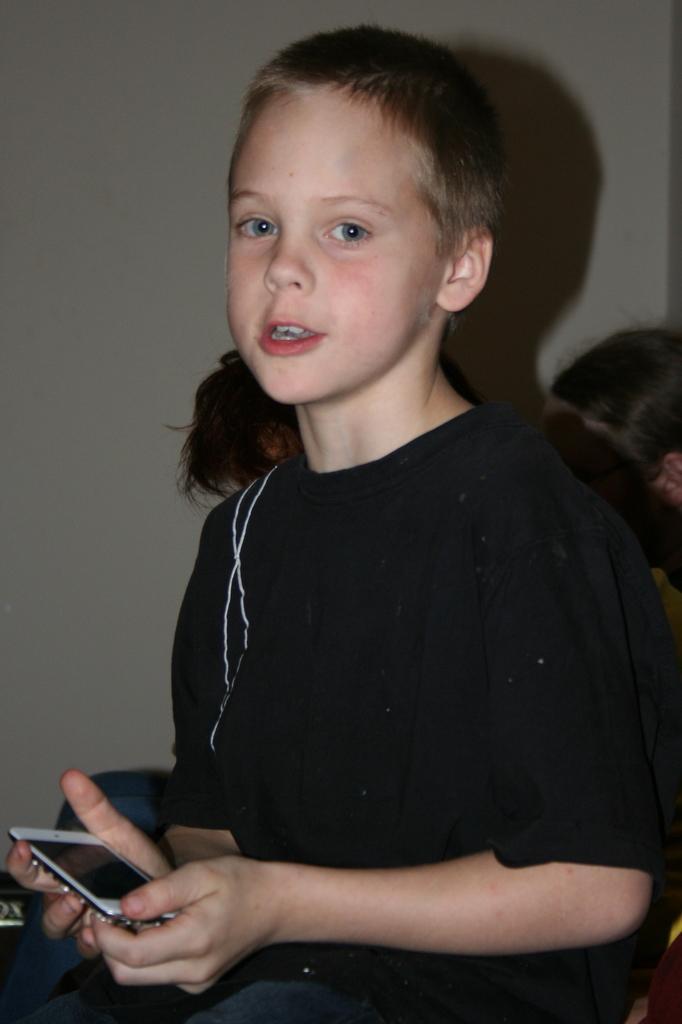Describe this image in one or two sentences. In the above picture there is kid holding a mobile phone in his hands. The kid is having black colored t shirt and a jeans. In the background i could see some two other person's head and the ear of the other person in right side of the picture. The kid is giving a smile to the picture. 